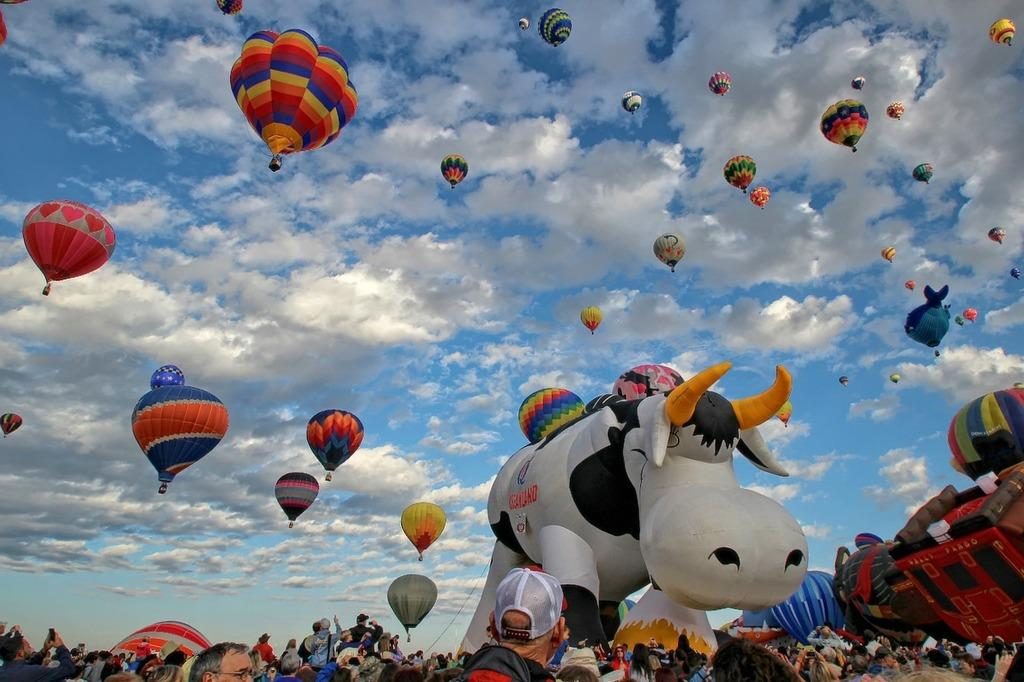What is the main subject of the image? The main subject of the image is many air balloons. Where are the air balloons located? The air balloons are in the air. What can be seen in the background of the image? There is sky visible in the background of the image, and clouds are present in the sky. Are there any people visible in the image? Yes, there are people visible at the bottom of the image. What is the tongue of the air balloon doing in the image? Air balloons do not have tongues, so this question is not applicable to the image. 